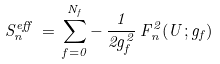Convert formula to latex. <formula><loc_0><loc_0><loc_500><loc_500>S ^ { e f f } _ { n } \, = \, \sum _ { f = 0 } ^ { N _ { f } } - \, \frac { 1 } { 2 g _ { f } ^ { 2 } } \, F ^ { 2 } _ { n } ( U ; g _ { f } )</formula> 